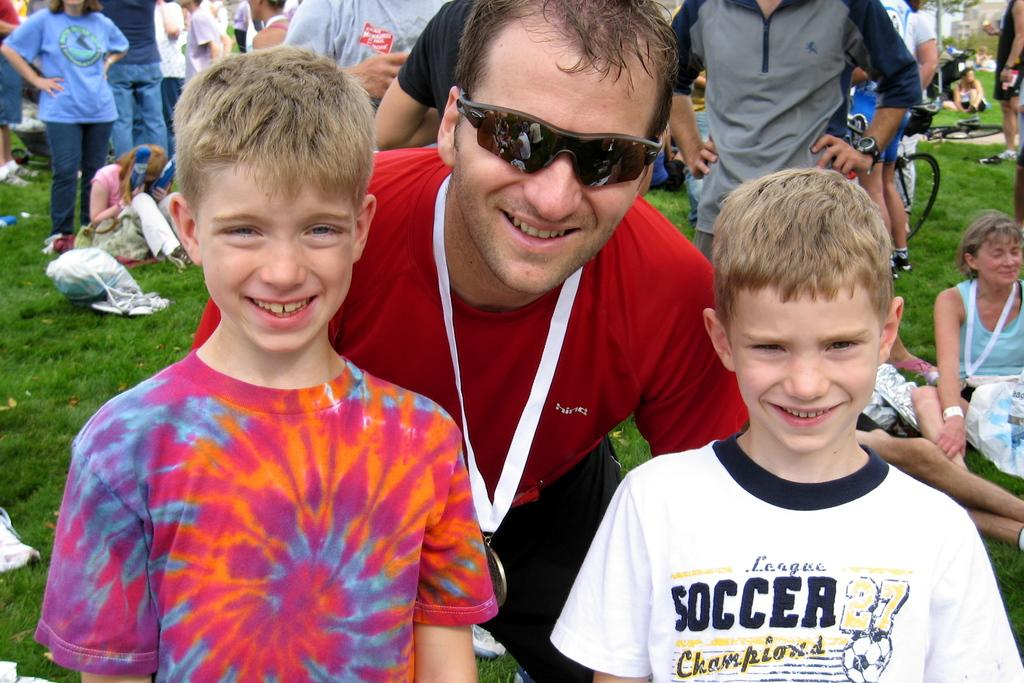What are the people in the image doing? There is a group of people standing on a path, and some people are sitting on the grass path. Can you describe the position of the people in the image? Some people are standing, while others are sitting on the grass. What else can be seen in the background of the image? There are other things visible behind the people, but the specific details are not mentioned in the facts. What type of pies are the people eating in the image? There is no mention of pies in the image, so it cannot be determined if they are present or being eaten. 